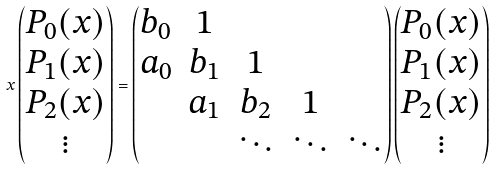Convert formula to latex. <formula><loc_0><loc_0><loc_500><loc_500>x \begin{pmatrix} P _ { 0 } ( x ) \\ P _ { 1 } ( x ) \\ P _ { 2 } ( x ) \\ \vdots \end{pmatrix} = \begin{pmatrix} b _ { 0 } & 1 & & & \\ a _ { 0 } & b _ { 1 } & 1 & \\ & a _ { 1 } & b _ { 2 } & 1 & \\ & & \ddots & \ddots & \ddots \end{pmatrix} \begin{pmatrix} P _ { 0 } ( x ) \\ P _ { 1 } ( x ) \\ P _ { 2 } ( x ) \\ \vdots \end{pmatrix}</formula> 